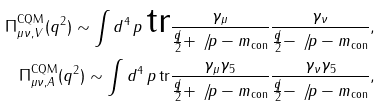Convert formula to latex. <formula><loc_0><loc_0><loc_500><loc_500>\Pi _ { \mu \nu , V } ^ { \text {CQM} } ( q ^ { 2 } ) \sim \int d ^ { 4 } \, p \, \text {tr} \frac { \gamma _ { \mu } } { \frac { \not { q } } { 2 } + \not { \, p } - m _ { \text {con} } } \frac { \gamma _ { \nu } } { \frac { \not { q } } { 2 } - \not { \, p } - m _ { \text {con} } } , \\ \Pi _ { \mu \nu , A } ^ { \text {CQM} } ( q ^ { 2 } ) \sim \int d ^ { 4 } \, p \, \text {tr} \frac { \gamma _ { \mu } \gamma _ { 5 } } { \frac { \not { q } } { 2 } + \not { \, p } - m _ { \text {con} } } \frac { \gamma _ { \nu } \gamma _ { 5 } } { \frac { \not { q } } { 2 } - \not { \, p } - m _ { \text {con} } } ,</formula> 